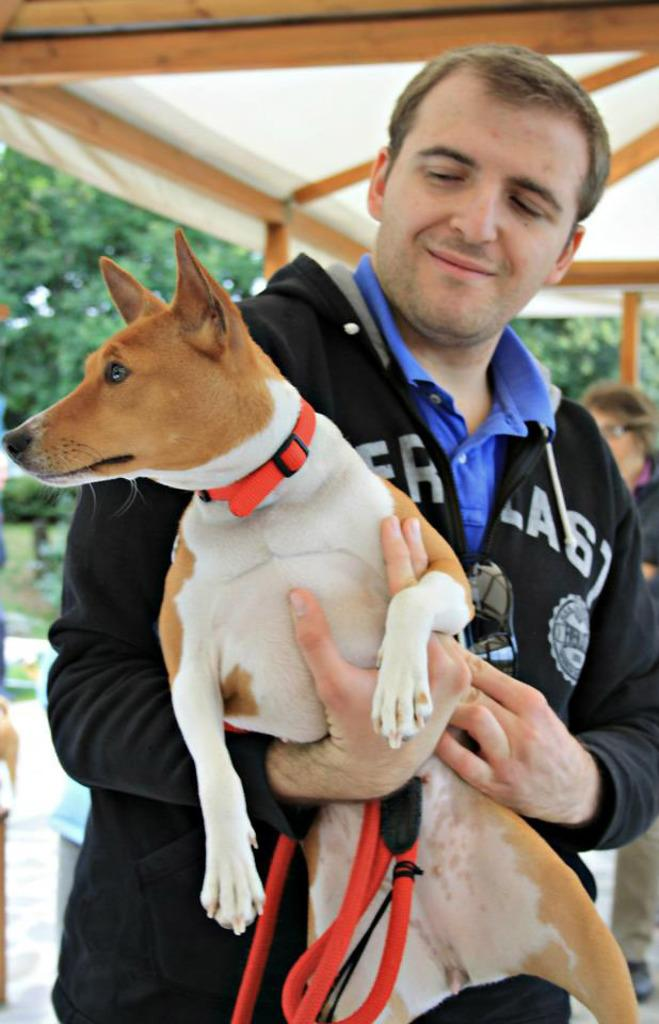Who is present in the image? There is a man in the image. What is the man holding in the image? The man is holding a dog in the image. Where is the dog located in relation to the man? The dog is in the man's hand. What is the man's facial expression in the image? The man is smiling in the image. What type of cast is visible on the man's arm in the image? There is no cast visible on the man's arm in the image. 